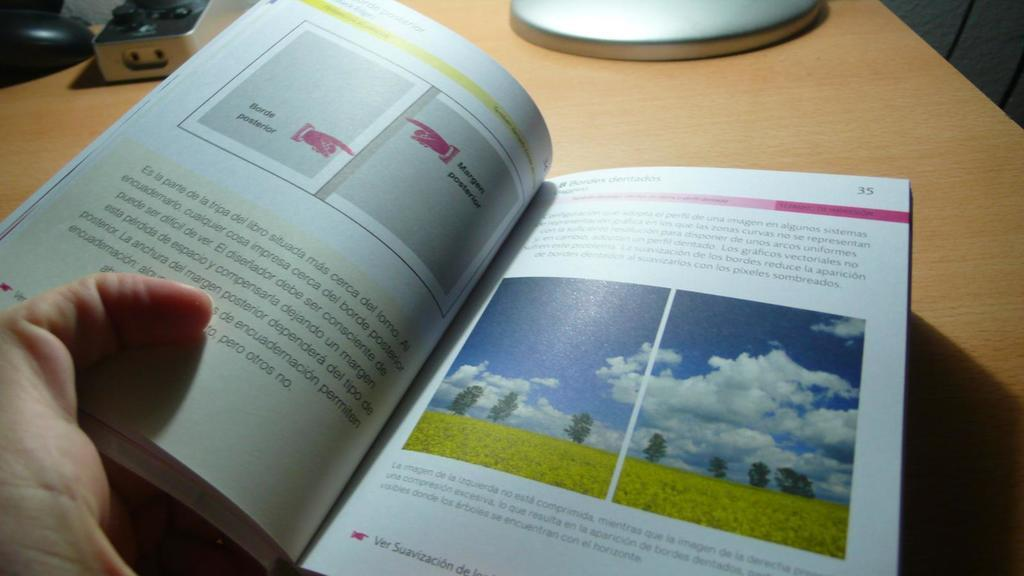<image>
Offer a succinct explanation of the picture presented. A reader is reading a book about Borde Posterior and is currently on page 35. 